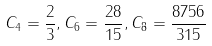Convert formula to latex. <formula><loc_0><loc_0><loc_500><loc_500>C _ { 4 } = \frac { 2 } { 3 } , C _ { 6 } = \frac { 2 8 } { 1 5 } , C _ { 8 } = \frac { 8 7 5 6 } { 3 1 5 }</formula> 